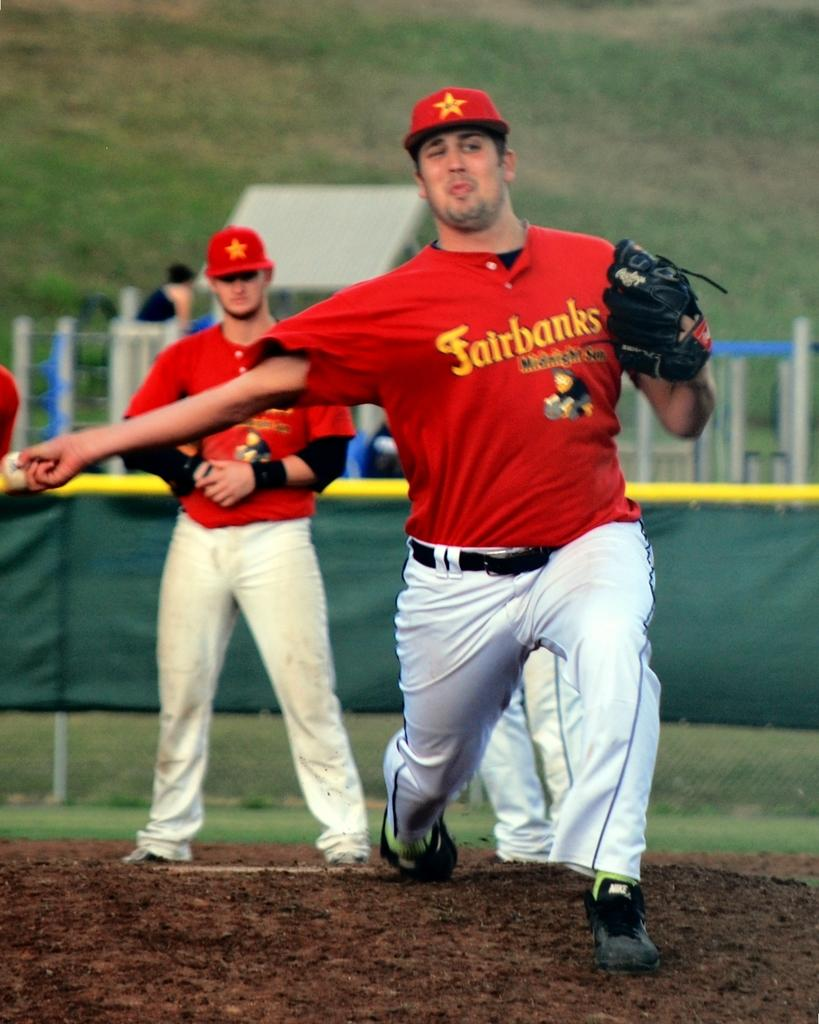<image>
Write a terse but informative summary of the picture. A baseball pitcher for the Fairbanks team is throwing a baseball. 